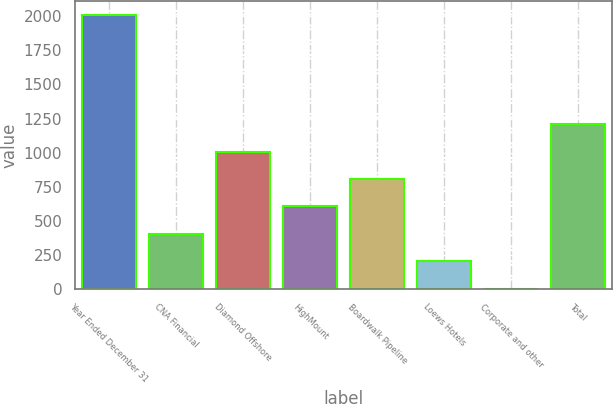<chart> <loc_0><loc_0><loc_500><loc_500><bar_chart><fcel>Year Ended December 31<fcel>CNA Financial<fcel>Diamond Offshore<fcel>HighMount<fcel>Boardwalk Pipeline<fcel>Loews Hotels<fcel>Corporate and other<fcel>Total<nl><fcel>2010<fcel>406<fcel>1007.5<fcel>606.5<fcel>807<fcel>205.5<fcel>5<fcel>1208<nl></chart> 